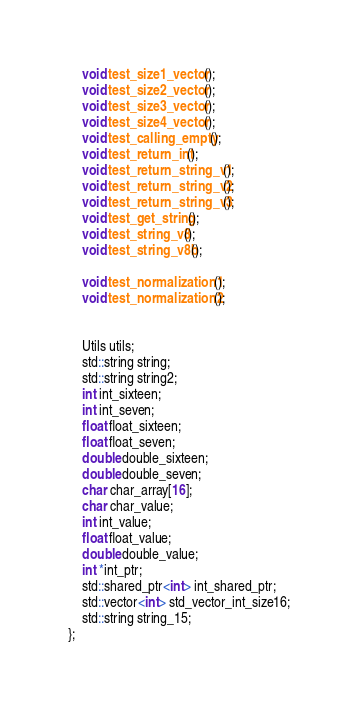Convert code to text. <code><loc_0><loc_0><loc_500><loc_500><_C_>	void test_size1_vector();
	void test_size2_vector();
	void test_size3_vector();
	void test_size4_vector();
	void test_calling_empty();
	void test_return_int();
	void test_return_string_v1();
	void test_return_string_v2();
	void test_return_string_v3();
	void test_get_string();
	void test_string_v8();
	void test_string_v8b();

	void test_normalization1();
	void test_normalization2();


	Utils utils;
	std::string string;
	std::string string2;
	int int_sixteen;
	int int_seven;
	float float_sixteen;
	float float_seven;
	double double_sixteen;
	double double_seven;
	char char_array[16];
	char char_value;
	int int_value;
	float float_value;
	double double_value;
	int *int_ptr;
	std::shared_ptr<int> int_shared_ptr;
	std::vector<int> std_vector_int_size16;
	std::string string_15;
};
</code> 